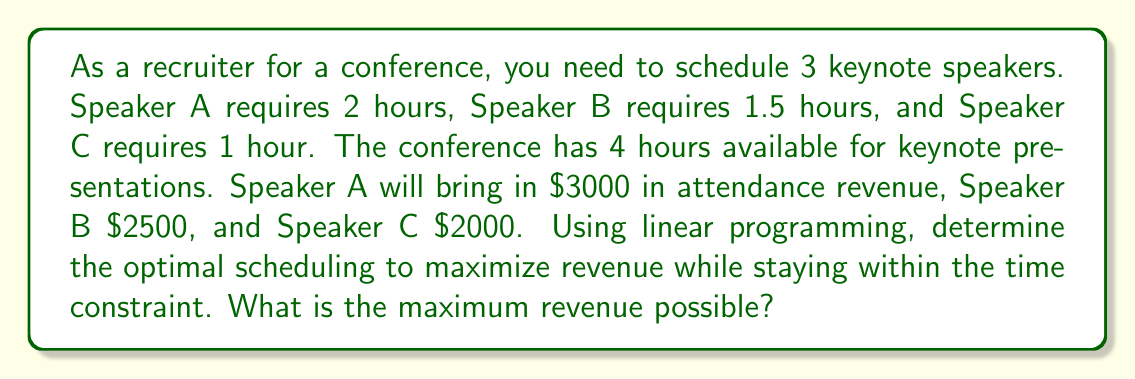Show me your answer to this math problem. Let's approach this step-by-step using linear programming:

1. Define variables:
   Let $x_A$, $x_B$, and $x_C$ be the number of times each speaker is scheduled (can be fractional).

2. Objective function:
   Maximize revenue: $Z = 3000x_A + 2500x_B + 2000x_C$

3. Constraints:
   Time constraint: $2x_A + 1.5x_B + x_C \leq 4$
   Non-negativity: $x_A, x_B, x_C \geq 0$

4. Set up the linear program:
   $$
   \begin{align*}
   \text{Maximize } & Z = 3000x_A + 2500x_B + 2000x_C \\
   \text{Subject to: } & 2x_A + 1.5x_B + x_C \leq 4 \\
   & x_A, x_B, x_C \geq 0
   \end{align*}
   $$

5. Solve using the simplex method or graphical method:
   The optimal solution is $x_A = 2$, $x_B = 0$, $x_C = 0$

6. Calculate the maximum revenue:
   $Z = 3000(2) + 2500(0) + 2000(0) = 6000$

Therefore, the optimal schedule is to have Speaker A present twice, utilizing the full 4 hours, and achieving a maximum revenue of $6000.
Answer: $6000 